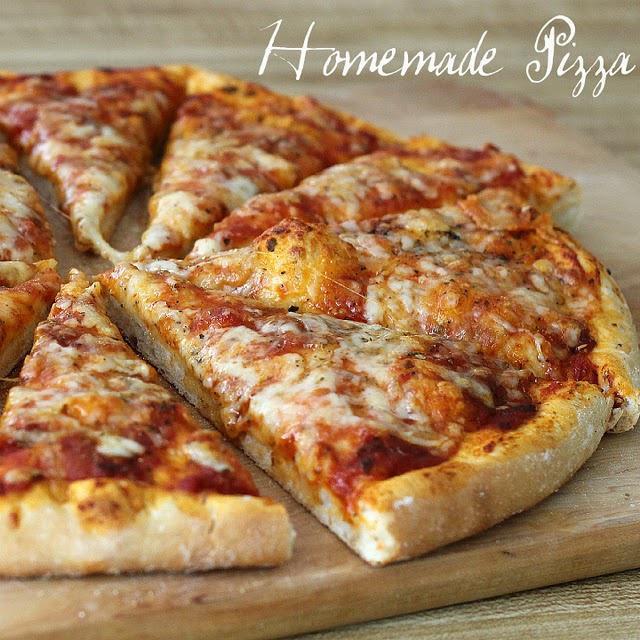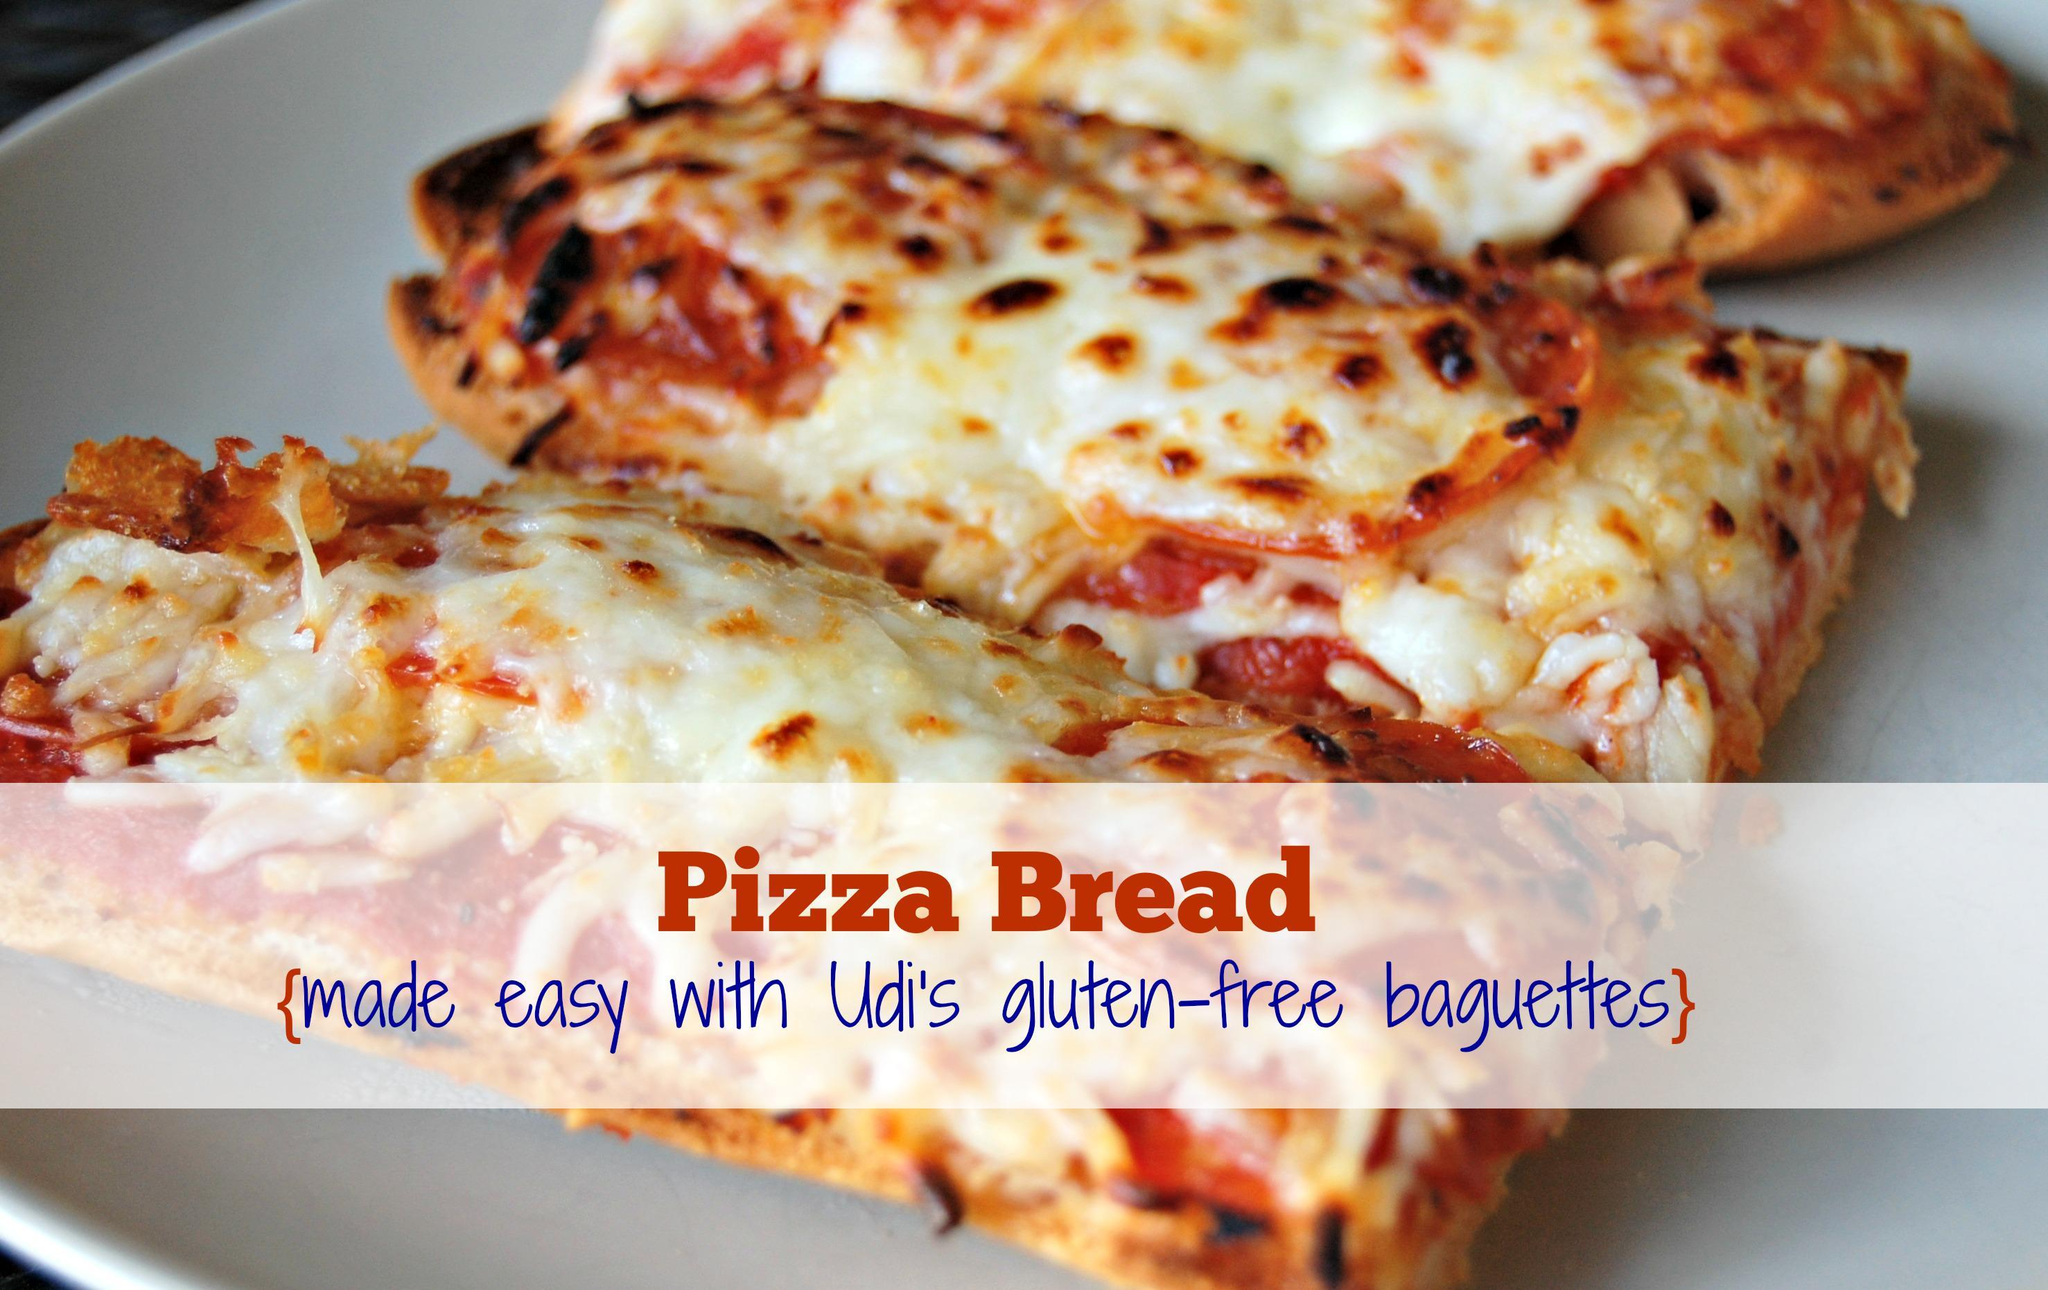The first image is the image on the left, the second image is the image on the right. For the images shown, is this caption "The left image shows a round pizza cut into slices on a wooden board, and the right image shows rectangles of pizza." true? Answer yes or no. Yes. The first image is the image on the left, the second image is the image on the right. For the images shown, is this caption "All pizzas are made on pieces of bread" true? Answer yes or no. No. 